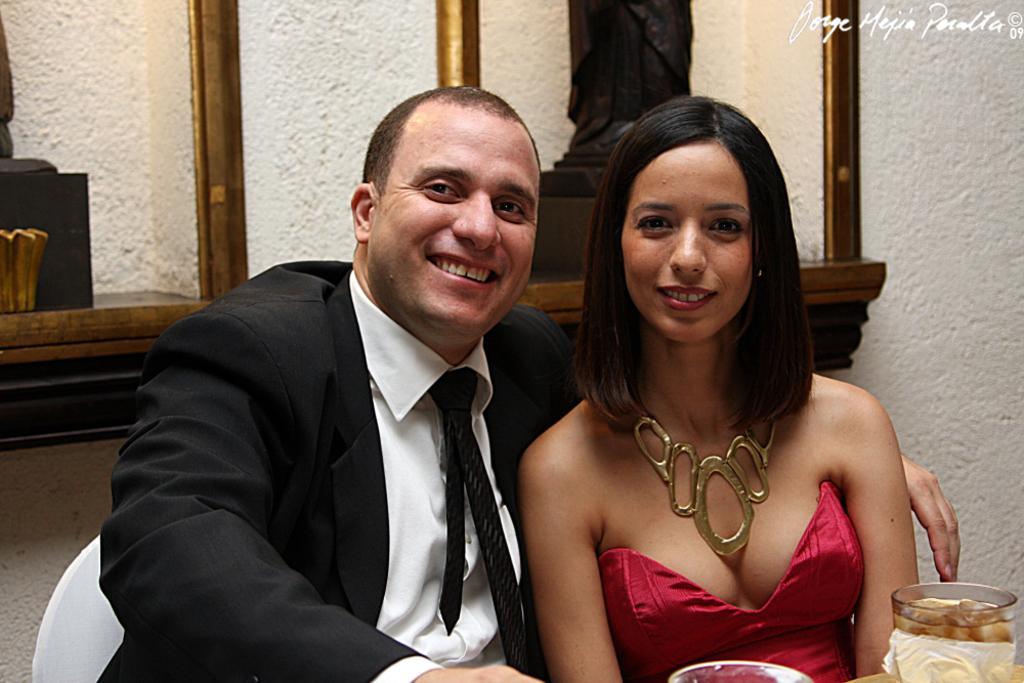Can you describe this image briefly? In this image, we can see persons wearing clothes. There is a glass in the bottom right of the image. In the background, we can see sculptures. 